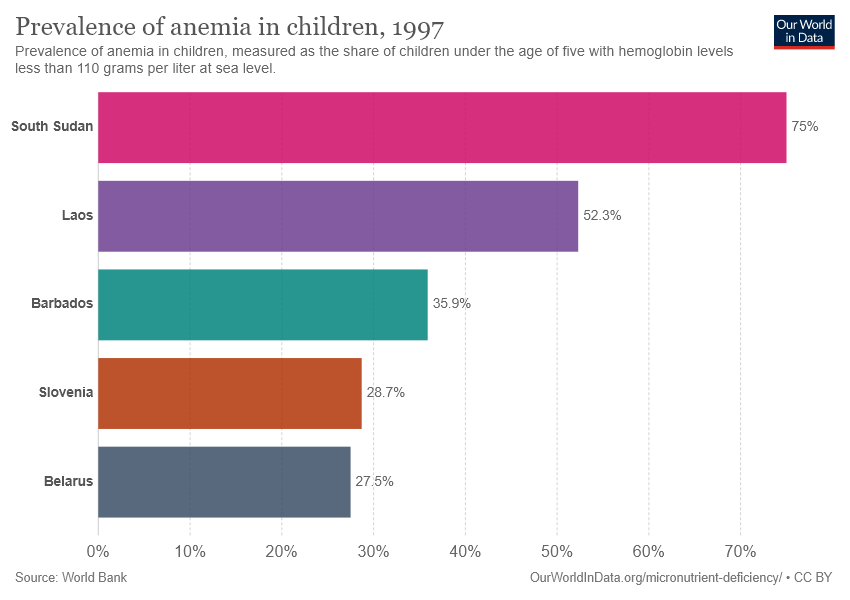Highlight a few significant elements in this photo. There are five categories in the chart. The average of the two smallest bars is 28.1. 